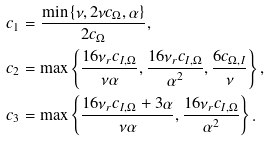Convert formula to latex. <formula><loc_0><loc_0><loc_500><loc_500>c _ { 1 } & = \frac { \min \left \{ \nu , 2 \nu c _ { \Omega } , \alpha \right \} } { 2 c _ { \Omega } } , \\ c _ { 2 } & = \max \left \{ \frac { 1 6 \nu _ { r } c _ { I , \Omega } } { \nu \alpha } , \frac { 1 6 \nu _ { r } c _ { I , \Omega } } { \alpha ^ { 2 } } , \frac { 6 c _ { \Omega , I } } { \nu } \right \} , \\ c _ { 3 } & = \max \left \{ \frac { 1 6 \nu _ { r } c _ { I , \Omega } + 3 \alpha } { \nu \alpha } , \frac { 1 6 \nu _ { r } c _ { I , \Omega } } { \alpha ^ { 2 } } \right \} .</formula> 